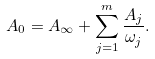Convert formula to latex. <formula><loc_0><loc_0><loc_500><loc_500>A _ { 0 } = A _ { \infty } + \sum _ { j = 1 } ^ { m } \frac { A _ { j } } { \omega _ { j } } .</formula> 